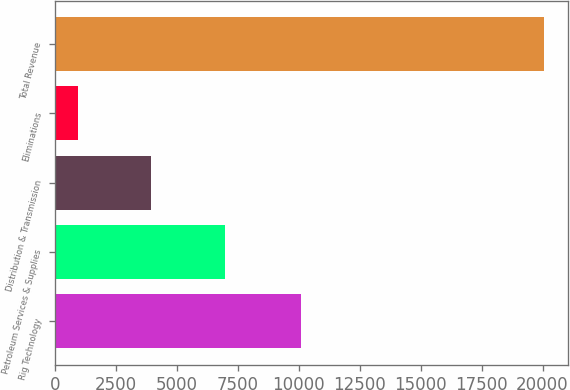<chart> <loc_0><loc_0><loc_500><loc_500><bar_chart><fcel>Rig Technology<fcel>Petroleum Services & Supplies<fcel>Distribution & Transmission<fcel>Eliminations<fcel>Total Revenue<nl><fcel>10107<fcel>6967<fcel>3927<fcel>960<fcel>20041<nl></chart> 